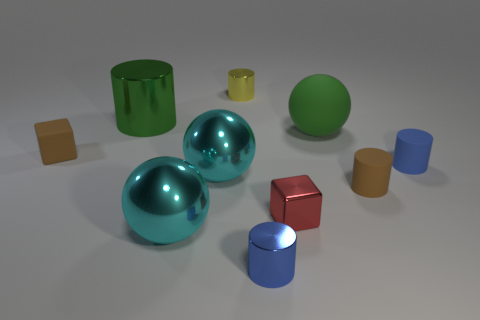Subtract all yellow cylinders. How many cylinders are left? 4 Subtract all green cylinders. How many cylinders are left? 4 Subtract all cyan cylinders. Subtract all cyan blocks. How many cylinders are left? 5 Subtract all balls. How many objects are left? 7 Subtract 0 brown spheres. How many objects are left? 10 Subtract all green metal cylinders. Subtract all green objects. How many objects are left? 7 Add 4 small cylinders. How many small cylinders are left? 8 Add 8 small red shiny things. How many small red shiny things exist? 9 